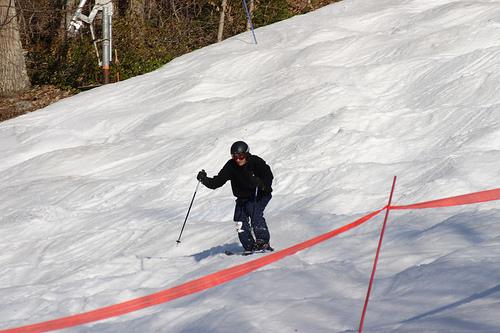Is the rope red?
Quick response, please. Yes. Is the person moving?
Write a very short answer. Yes. Is the person snowboarding?
Answer briefly. No. 